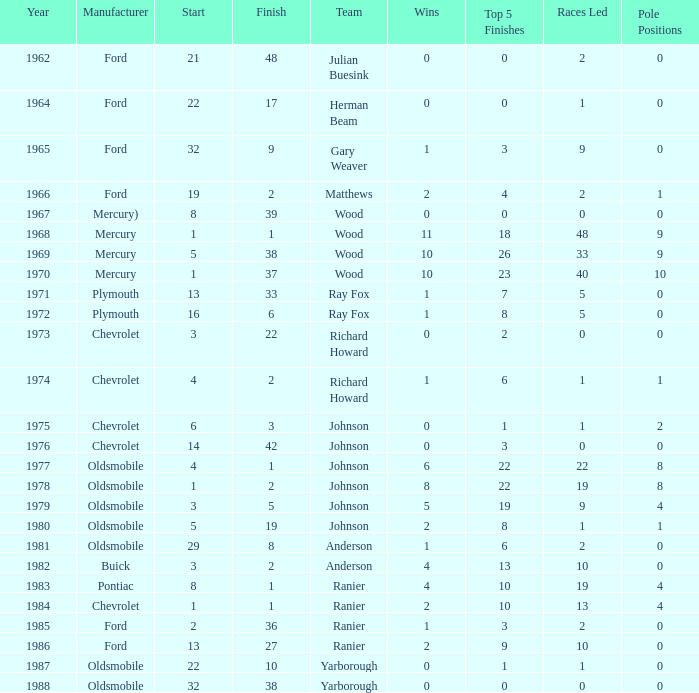Who was the maufacturer of the vehicle during the race where Cale Yarborough started at 19 and finished earlier than 42? Ford. 